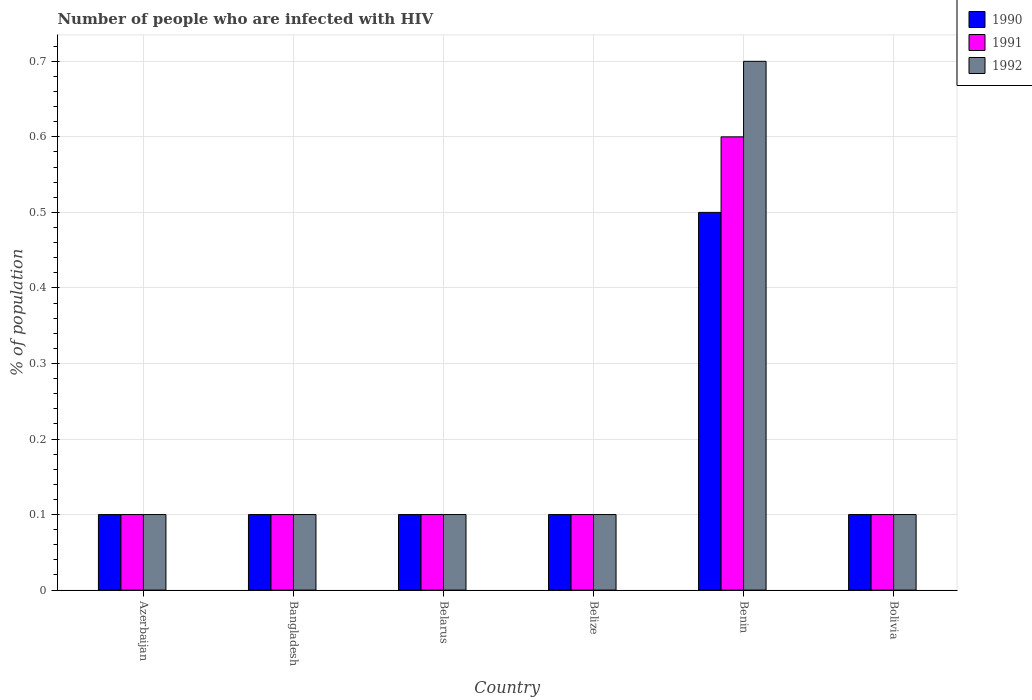How many groups of bars are there?
Give a very brief answer. 6. Are the number of bars per tick equal to the number of legend labels?
Your answer should be compact. Yes. Are the number of bars on each tick of the X-axis equal?
Give a very brief answer. Yes. Across all countries, what is the maximum percentage of HIV infected population in in 1990?
Your answer should be very brief. 0.5. In which country was the percentage of HIV infected population in in 1991 maximum?
Your answer should be compact. Benin. In which country was the percentage of HIV infected population in in 1992 minimum?
Make the answer very short. Azerbaijan. What is the total percentage of HIV infected population in in 1992 in the graph?
Give a very brief answer. 1.2. What is the average percentage of HIV infected population in in 1992 per country?
Offer a terse response. 0.2. In how many countries, is the percentage of HIV infected population in in 1992 greater than 0.6400000000000001 %?
Your response must be concise. 1. In how many countries, is the percentage of HIV infected population in in 1991 greater than the average percentage of HIV infected population in in 1991 taken over all countries?
Provide a succinct answer. 1. Is the sum of the percentage of HIV infected population in in 1992 in Bangladesh and Belarus greater than the maximum percentage of HIV infected population in in 1990 across all countries?
Ensure brevity in your answer.  No. What does the 1st bar from the right in Belize represents?
Ensure brevity in your answer.  1992. How many countries are there in the graph?
Offer a very short reply. 6. What is the difference between two consecutive major ticks on the Y-axis?
Your answer should be compact. 0.1. Does the graph contain grids?
Your response must be concise. Yes. Where does the legend appear in the graph?
Your answer should be very brief. Top right. What is the title of the graph?
Make the answer very short. Number of people who are infected with HIV. What is the label or title of the Y-axis?
Offer a very short reply. % of population. What is the % of population in 1991 in Azerbaijan?
Your answer should be compact. 0.1. What is the % of population of 1992 in Azerbaijan?
Your answer should be compact. 0.1. What is the % of population in 1990 in Bangladesh?
Provide a succinct answer. 0.1. What is the % of population of 1992 in Bangladesh?
Ensure brevity in your answer.  0.1. What is the % of population in 1992 in Belize?
Your response must be concise. 0.1. What is the % of population in 1992 in Benin?
Provide a short and direct response. 0.7. What is the % of population of 1991 in Bolivia?
Provide a succinct answer. 0.1. What is the % of population in 1992 in Bolivia?
Provide a short and direct response. 0.1. Across all countries, what is the minimum % of population of 1991?
Give a very brief answer. 0.1. Across all countries, what is the minimum % of population of 1992?
Your answer should be compact. 0.1. What is the total % of population in 1990 in the graph?
Your answer should be compact. 1. What is the total % of population in 1991 in the graph?
Provide a succinct answer. 1.1. What is the difference between the % of population in 1990 in Azerbaijan and that in Bangladesh?
Your response must be concise. 0. What is the difference between the % of population in 1992 in Azerbaijan and that in Bangladesh?
Provide a succinct answer. 0. What is the difference between the % of population in 1990 in Azerbaijan and that in Belarus?
Your answer should be very brief. 0. What is the difference between the % of population of 1992 in Azerbaijan and that in Belarus?
Ensure brevity in your answer.  0. What is the difference between the % of population of 1992 in Azerbaijan and that in Belize?
Offer a very short reply. 0. What is the difference between the % of population of 1991 in Azerbaijan and that in Benin?
Provide a succinct answer. -0.5. What is the difference between the % of population of 1992 in Azerbaijan and that in Benin?
Make the answer very short. -0.6. What is the difference between the % of population in 1990 in Azerbaijan and that in Bolivia?
Offer a terse response. 0. What is the difference between the % of population in 1991 in Azerbaijan and that in Bolivia?
Provide a short and direct response. 0. What is the difference between the % of population in 1992 in Azerbaijan and that in Bolivia?
Make the answer very short. 0. What is the difference between the % of population in 1992 in Bangladesh and that in Belize?
Offer a terse response. 0. What is the difference between the % of population of 1992 in Bangladesh and that in Benin?
Give a very brief answer. -0.6. What is the difference between the % of population of 1992 in Bangladesh and that in Bolivia?
Keep it short and to the point. 0. What is the difference between the % of population in 1990 in Belarus and that in Belize?
Ensure brevity in your answer.  0. What is the difference between the % of population of 1991 in Belarus and that in Belize?
Your answer should be very brief. 0. What is the difference between the % of population in 1992 in Belarus and that in Belize?
Offer a very short reply. 0. What is the difference between the % of population of 1991 in Belarus and that in Benin?
Make the answer very short. -0.5. What is the difference between the % of population of 1990 in Belarus and that in Bolivia?
Give a very brief answer. 0. What is the difference between the % of population in 1992 in Belarus and that in Bolivia?
Offer a very short reply. 0. What is the difference between the % of population of 1990 in Belize and that in Benin?
Make the answer very short. -0.4. What is the difference between the % of population of 1992 in Belize and that in Benin?
Your answer should be compact. -0.6. What is the difference between the % of population in 1992 in Belize and that in Bolivia?
Make the answer very short. 0. What is the difference between the % of population in 1990 in Benin and that in Bolivia?
Make the answer very short. 0.4. What is the difference between the % of population of 1991 in Benin and that in Bolivia?
Ensure brevity in your answer.  0.5. What is the difference between the % of population of 1992 in Benin and that in Bolivia?
Your answer should be compact. 0.6. What is the difference between the % of population of 1991 in Azerbaijan and the % of population of 1992 in Bangladesh?
Make the answer very short. 0. What is the difference between the % of population of 1990 in Azerbaijan and the % of population of 1992 in Belarus?
Offer a very short reply. 0. What is the difference between the % of population of 1991 in Azerbaijan and the % of population of 1992 in Belarus?
Keep it short and to the point. 0. What is the difference between the % of population in 1990 in Azerbaijan and the % of population in 1992 in Belize?
Offer a very short reply. 0. What is the difference between the % of population of 1991 in Azerbaijan and the % of population of 1992 in Belize?
Your answer should be very brief. 0. What is the difference between the % of population of 1990 in Azerbaijan and the % of population of 1992 in Benin?
Your answer should be compact. -0.6. What is the difference between the % of population in 1991 in Azerbaijan and the % of population in 1992 in Benin?
Make the answer very short. -0.6. What is the difference between the % of population of 1990 in Azerbaijan and the % of population of 1991 in Bolivia?
Your response must be concise. 0. What is the difference between the % of population in 1990 in Azerbaijan and the % of population in 1992 in Bolivia?
Your response must be concise. 0. What is the difference between the % of population in 1990 in Bangladesh and the % of population in 1991 in Belarus?
Your response must be concise. 0. What is the difference between the % of population of 1990 in Bangladesh and the % of population of 1991 in Belize?
Your response must be concise. 0. What is the difference between the % of population in 1990 in Bangladesh and the % of population in 1992 in Belize?
Keep it short and to the point. 0. What is the difference between the % of population in 1991 in Bangladesh and the % of population in 1992 in Benin?
Provide a short and direct response. -0.6. What is the difference between the % of population of 1990 in Bangladesh and the % of population of 1991 in Bolivia?
Provide a succinct answer. 0. What is the difference between the % of population in 1990 in Belarus and the % of population in 1991 in Belize?
Offer a terse response. 0. What is the difference between the % of population of 1990 in Belarus and the % of population of 1992 in Belize?
Offer a very short reply. 0. What is the difference between the % of population of 1990 in Belarus and the % of population of 1991 in Benin?
Your answer should be very brief. -0.5. What is the difference between the % of population of 1990 in Belarus and the % of population of 1992 in Benin?
Offer a very short reply. -0.6. What is the difference between the % of population of 1991 in Belarus and the % of population of 1992 in Benin?
Offer a very short reply. -0.6. What is the difference between the % of population of 1990 in Belarus and the % of population of 1991 in Bolivia?
Your answer should be compact. 0. What is the difference between the % of population of 1990 in Belarus and the % of population of 1992 in Bolivia?
Ensure brevity in your answer.  0. What is the difference between the % of population of 1991 in Belarus and the % of population of 1992 in Bolivia?
Give a very brief answer. 0. What is the difference between the % of population in 1990 in Belize and the % of population in 1992 in Benin?
Keep it short and to the point. -0.6. What is the difference between the % of population in 1990 in Belize and the % of population in 1992 in Bolivia?
Provide a succinct answer. 0. What is the difference between the % of population of 1990 in Benin and the % of population of 1991 in Bolivia?
Give a very brief answer. 0.4. What is the average % of population in 1990 per country?
Your answer should be very brief. 0.17. What is the average % of population in 1991 per country?
Make the answer very short. 0.18. What is the average % of population in 1992 per country?
Ensure brevity in your answer.  0.2. What is the difference between the % of population of 1990 and % of population of 1992 in Azerbaijan?
Your response must be concise. 0. What is the difference between the % of population of 1991 and % of population of 1992 in Bangladesh?
Offer a terse response. 0. What is the difference between the % of population of 1990 and % of population of 1992 in Belarus?
Your response must be concise. 0. What is the difference between the % of population in 1991 and % of population in 1992 in Belarus?
Offer a terse response. 0. What is the difference between the % of population of 1990 and % of population of 1991 in Belize?
Give a very brief answer. 0. What is the difference between the % of population of 1990 and % of population of 1991 in Benin?
Offer a very short reply. -0.1. What is the difference between the % of population of 1991 and % of population of 1992 in Benin?
Ensure brevity in your answer.  -0.1. What is the difference between the % of population of 1990 and % of population of 1991 in Bolivia?
Ensure brevity in your answer.  0. What is the difference between the % of population in 1991 and % of population in 1992 in Bolivia?
Keep it short and to the point. 0. What is the ratio of the % of population of 1990 in Azerbaijan to that in Bangladesh?
Make the answer very short. 1. What is the ratio of the % of population of 1991 in Azerbaijan to that in Belarus?
Your response must be concise. 1. What is the ratio of the % of population of 1992 in Azerbaijan to that in Belarus?
Your response must be concise. 1. What is the ratio of the % of population in 1990 in Azerbaijan to that in Belize?
Ensure brevity in your answer.  1. What is the ratio of the % of population in 1991 in Azerbaijan to that in Belize?
Provide a succinct answer. 1. What is the ratio of the % of population in 1990 in Azerbaijan to that in Benin?
Keep it short and to the point. 0.2. What is the ratio of the % of population in 1991 in Azerbaijan to that in Benin?
Your response must be concise. 0.17. What is the ratio of the % of population in 1992 in Azerbaijan to that in Benin?
Provide a short and direct response. 0.14. What is the ratio of the % of population of 1990 in Bangladesh to that in Belize?
Your answer should be compact. 1. What is the ratio of the % of population in 1991 in Bangladesh to that in Belize?
Offer a very short reply. 1. What is the ratio of the % of population of 1991 in Bangladesh to that in Benin?
Ensure brevity in your answer.  0.17. What is the ratio of the % of population of 1992 in Bangladesh to that in Benin?
Provide a succinct answer. 0.14. What is the ratio of the % of population in 1990 in Bangladesh to that in Bolivia?
Offer a terse response. 1. What is the ratio of the % of population of 1992 in Bangladesh to that in Bolivia?
Your response must be concise. 1. What is the ratio of the % of population in 1990 in Belarus to that in Belize?
Give a very brief answer. 1. What is the ratio of the % of population in 1992 in Belarus to that in Belize?
Offer a very short reply. 1. What is the ratio of the % of population of 1991 in Belarus to that in Benin?
Offer a terse response. 0.17. What is the ratio of the % of population in 1992 in Belarus to that in Benin?
Offer a terse response. 0.14. What is the ratio of the % of population in 1991 in Belarus to that in Bolivia?
Your response must be concise. 1. What is the ratio of the % of population in 1992 in Belarus to that in Bolivia?
Your answer should be very brief. 1. What is the ratio of the % of population of 1991 in Belize to that in Benin?
Offer a terse response. 0.17. What is the ratio of the % of population of 1992 in Belize to that in Benin?
Ensure brevity in your answer.  0.14. What is the ratio of the % of population of 1990 in Belize to that in Bolivia?
Ensure brevity in your answer.  1. What is the ratio of the % of population of 1991 in Belize to that in Bolivia?
Provide a succinct answer. 1. What is the ratio of the % of population of 1990 in Benin to that in Bolivia?
Keep it short and to the point. 5. What is the ratio of the % of population of 1991 in Benin to that in Bolivia?
Your response must be concise. 6. What is the ratio of the % of population of 1992 in Benin to that in Bolivia?
Keep it short and to the point. 7. What is the difference between the highest and the lowest % of population of 1990?
Provide a succinct answer. 0.4. What is the difference between the highest and the lowest % of population of 1992?
Ensure brevity in your answer.  0.6. 